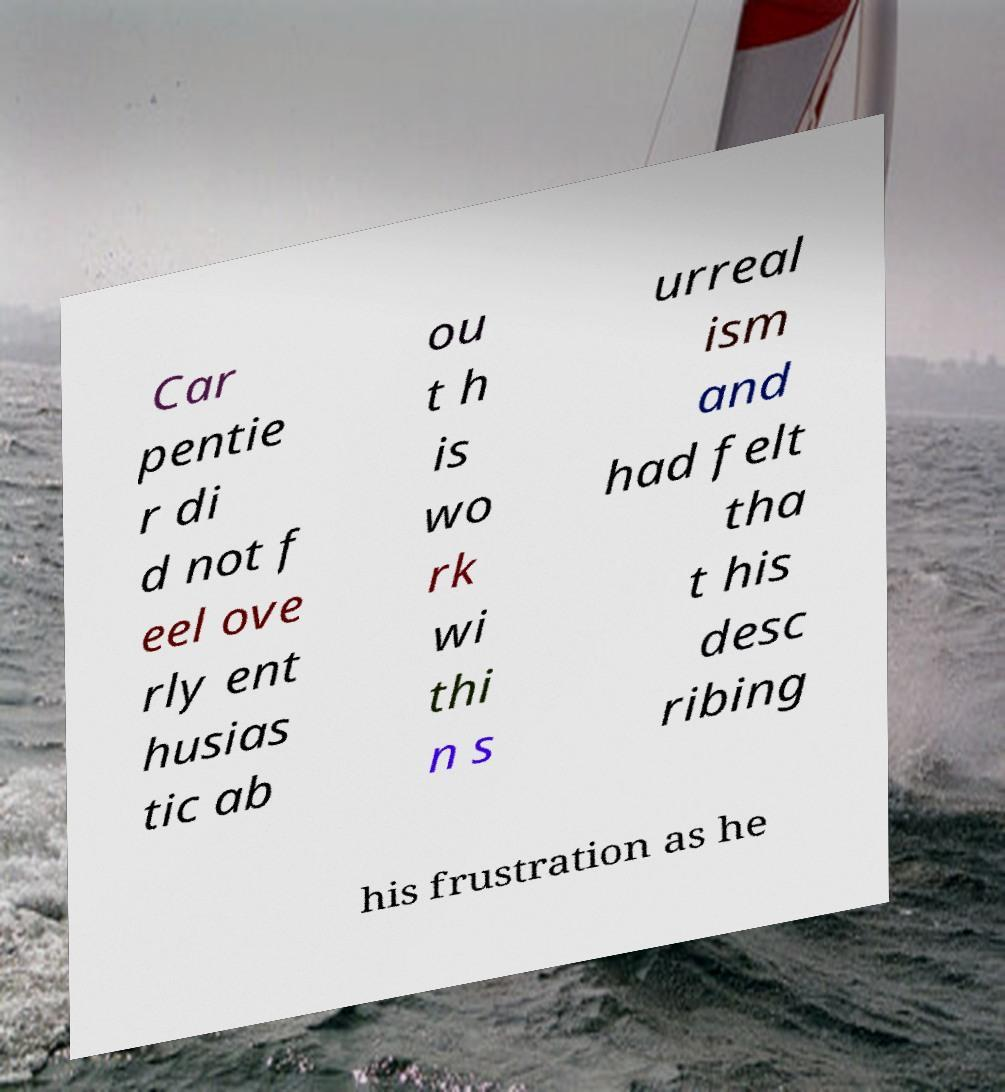Please read and relay the text visible in this image. What does it say? Car pentie r di d not f eel ove rly ent husias tic ab ou t h is wo rk wi thi n s urreal ism and had felt tha t his desc ribing his frustration as he 